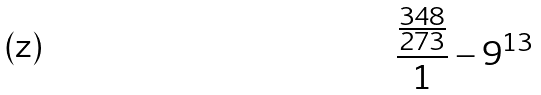<formula> <loc_0><loc_0><loc_500><loc_500>\frac { \frac { 3 4 8 } { 2 7 3 } } { 1 } - 9 ^ { 1 3 }</formula> 